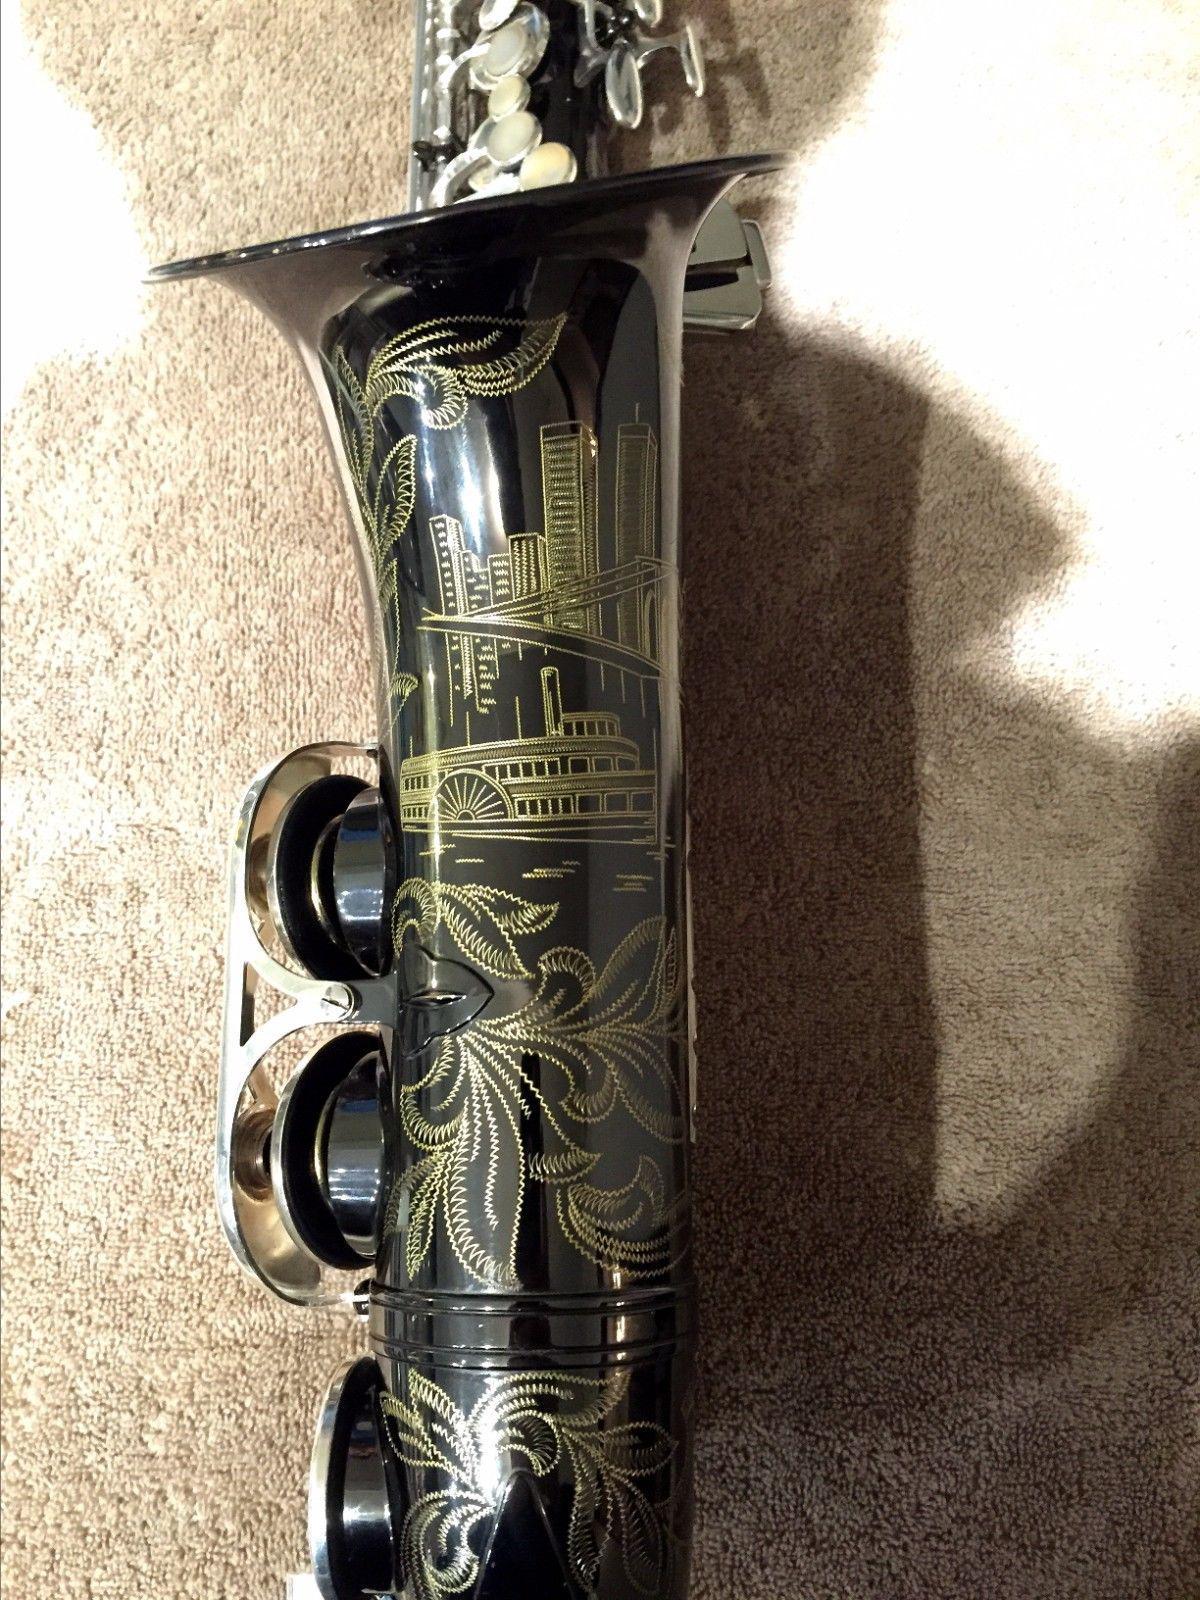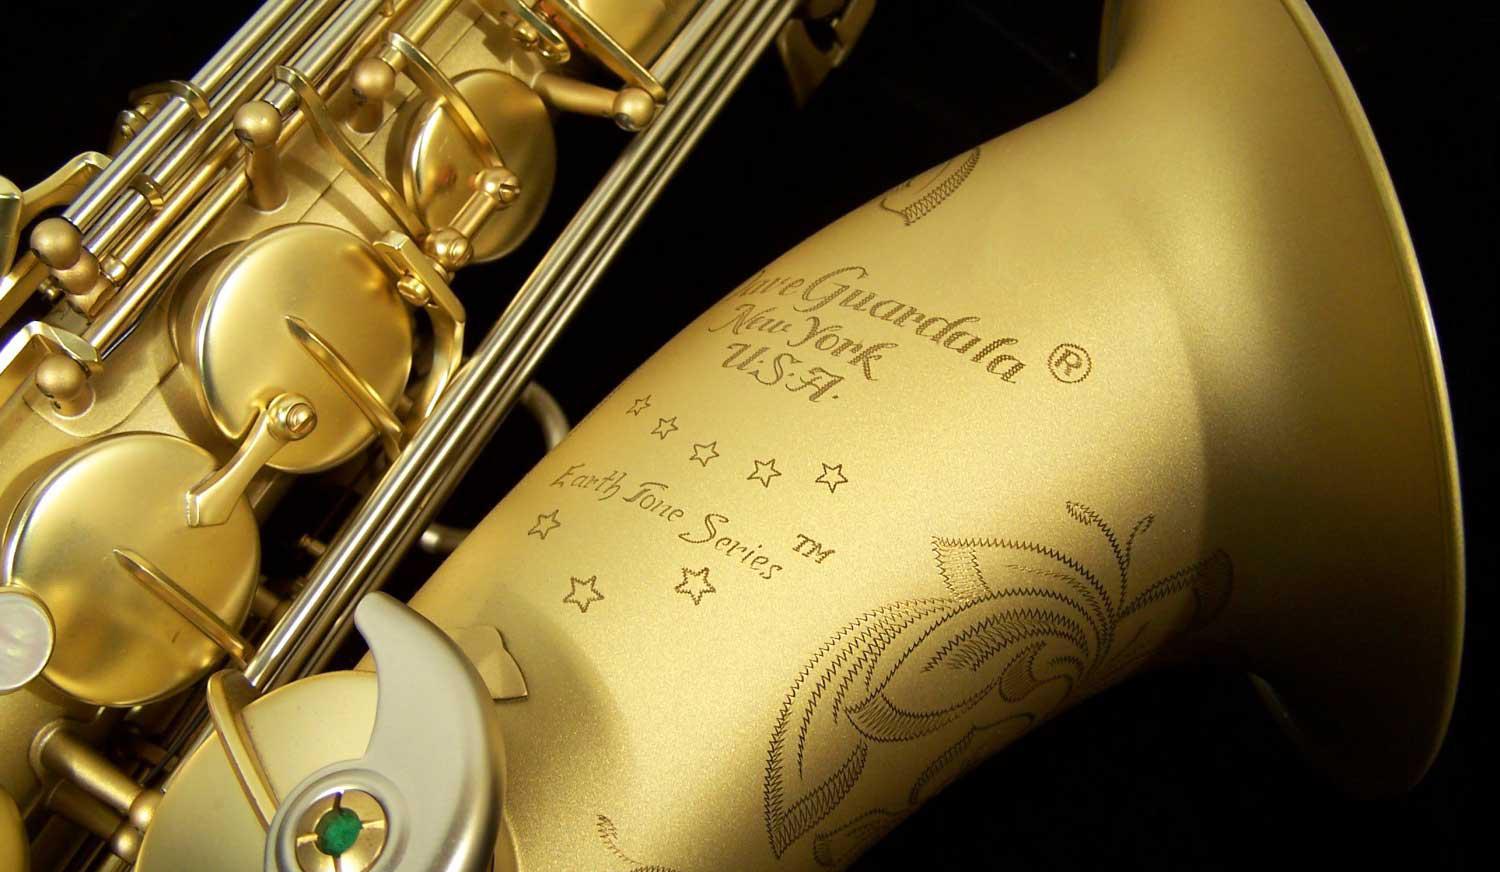The first image is the image on the left, the second image is the image on the right. Examine the images to the left and right. Is the description "An image shows a gold-colored saxophone with floral etchings on the bell and a non-shiny exterior finish, displayed on black without wrinkles." accurate? Answer yes or no. Yes. The first image is the image on the left, the second image is the image on the right. For the images displayed, is the sentence "The saxophones are all sitting on black materials." factually correct? Answer yes or no. No. 